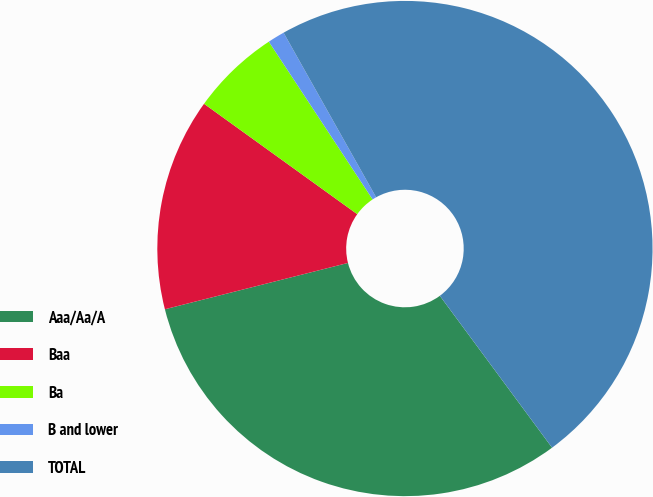Convert chart. <chart><loc_0><loc_0><loc_500><loc_500><pie_chart><fcel>Aaa/Aa/A<fcel>Baa<fcel>Ba<fcel>B and lower<fcel>TOTAL<nl><fcel>31.18%<fcel>13.88%<fcel>5.8%<fcel>1.11%<fcel>48.02%<nl></chart> 